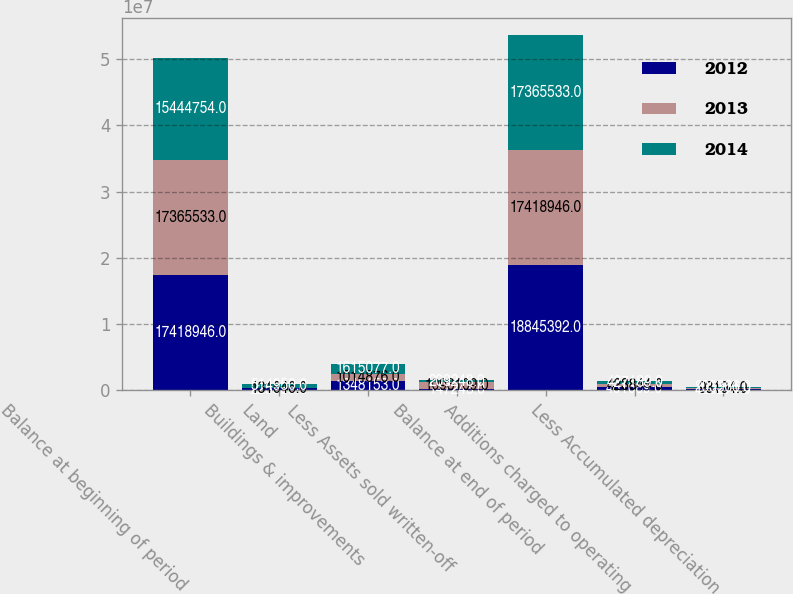<chart> <loc_0><loc_0><loc_500><loc_500><stacked_bar_chart><ecel><fcel>Balance at beginning of period<fcel>Land<fcel>Buildings & improvements<fcel>Less Assets sold written-off<fcel>Balance at end of period<fcel>Additions charged to operating<fcel>Less Accumulated depreciation<nl><fcel>2012<fcel>1.74189e+07<fcel>225536<fcel>1.34815e+06<fcel>147243<fcel>1.88454e+07<fcel>461689<fcel>129271<nl><fcel>2013<fcel>1.73655e+07<fcel>131646<fcel>1.01488e+06<fcel>1.09311e+06<fcel>1.74189e+07<fcel>423844<fcel>93194<nl><fcel>2014<fcel>1.54448e+07<fcel>514950<fcel>1.61508e+06<fcel>209248<fcel>1.73655e+07<fcel>427189<fcel>203366<nl></chart> 